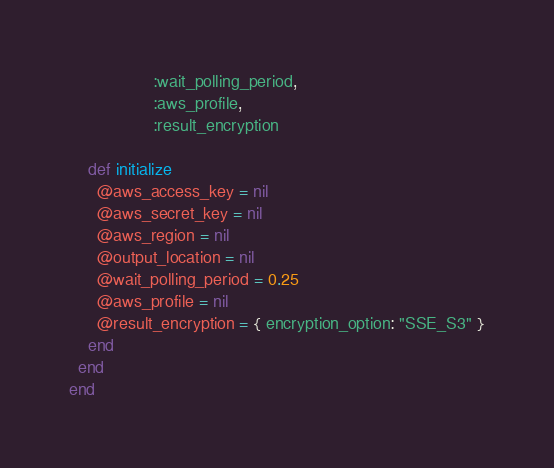<code> <loc_0><loc_0><loc_500><loc_500><_Ruby_>                  :wait_polling_period,
                  :aws_profile,
                  :result_encryption

    def initialize
      @aws_access_key = nil
      @aws_secret_key = nil
      @aws_region = nil
      @output_location = nil
      @wait_polling_period = 0.25
      @aws_profile = nil
      @result_encryption = { encryption_option: "SSE_S3" }
    end
  end
end
</code> 